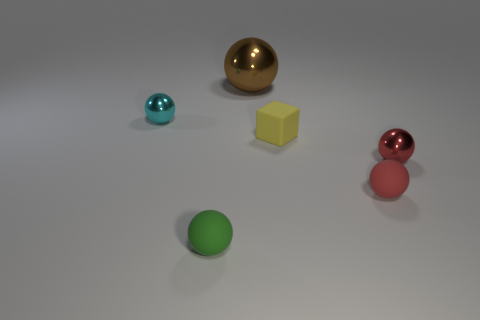The metal sphere that is in front of the brown sphere and left of the yellow rubber cube is what color?
Your response must be concise. Cyan. What number of large brown shiny things are in front of the small rubber cube?
Offer a terse response. 0. What is the material of the cyan sphere?
Your response must be concise. Metal. There is a metal sphere behind the tiny shiny sphere that is behind the metallic sphere in front of the cyan shiny sphere; what color is it?
Ensure brevity in your answer.  Brown. How many green balls are the same size as the brown metallic thing?
Ensure brevity in your answer.  0. There is a small matte sphere that is on the left side of the big brown metal sphere; what is its color?
Offer a terse response. Green. How many other things are there of the same size as the block?
Ensure brevity in your answer.  4. There is a ball that is to the right of the small cyan thing and behind the tiny yellow rubber block; what size is it?
Your answer should be compact. Large. There is a block; is its color the same as the small matte ball to the right of the green sphere?
Offer a terse response. No. Are there any other tiny metallic objects of the same shape as the red metallic object?
Your answer should be very brief. Yes. 